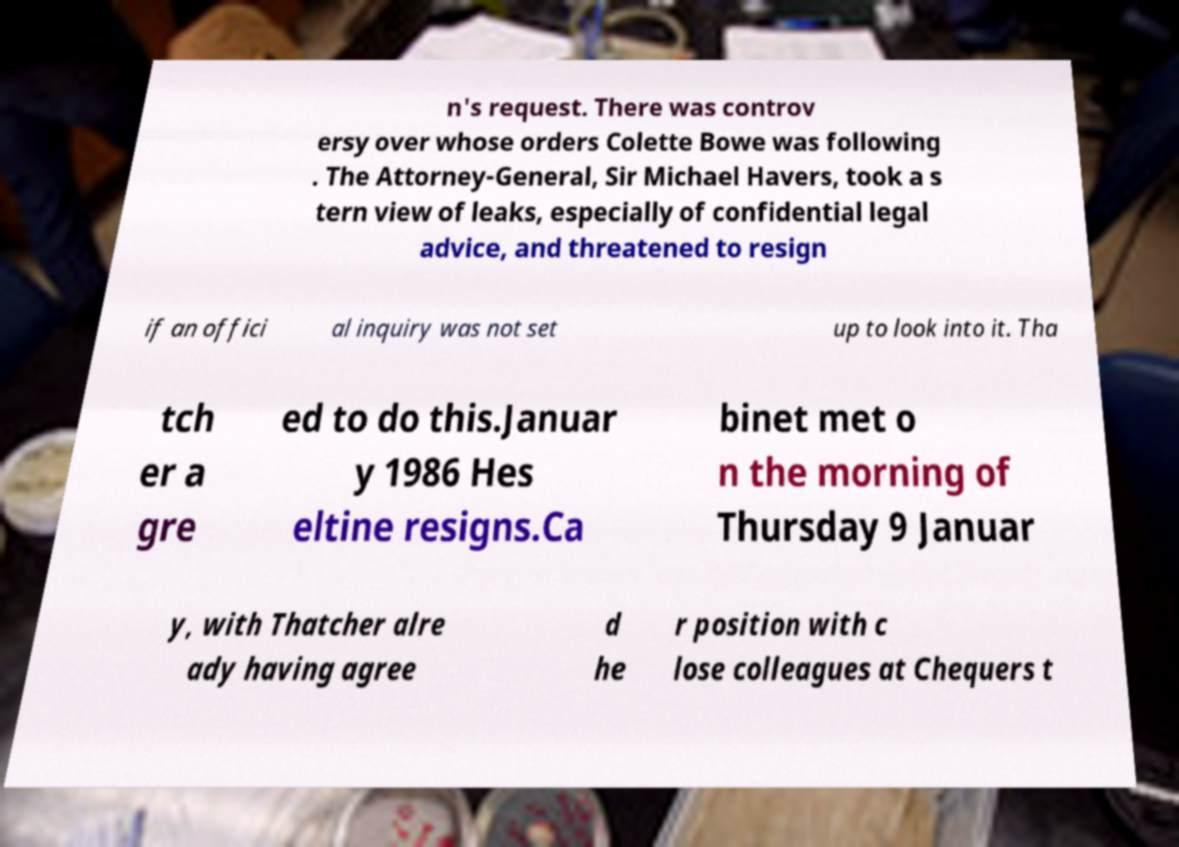Please identify and transcribe the text found in this image. n's request. There was controv ersy over whose orders Colette Bowe was following . The Attorney-General, Sir Michael Havers, took a s tern view of leaks, especially of confidential legal advice, and threatened to resign if an offici al inquiry was not set up to look into it. Tha tch er a gre ed to do this.Januar y 1986 Hes eltine resigns.Ca binet met o n the morning of Thursday 9 Januar y, with Thatcher alre ady having agree d he r position with c lose colleagues at Chequers t 